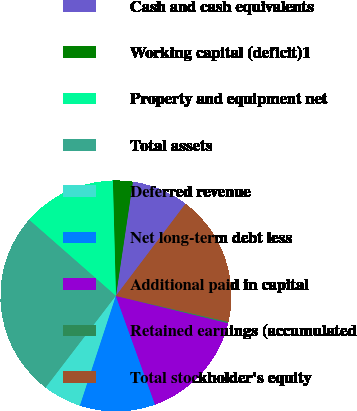Convert chart. <chart><loc_0><loc_0><loc_500><loc_500><pie_chart><fcel>Cash and cash equivalents<fcel>Working capital (deficit)1<fcel>Property and equipment net<fcel>Total assets<fcel>Deferred revenue<fcel>Net long-term debt less<fcel>Additional paid in capital<fcel>Retained earnings (accumulated<fcel>Total stockholder's equity<nl><fcel>7.95%<fcel>2.77%<fcel>13.12%<fcel>26.06%<fcel>5.36%<fcel>10.54%<fcel>15.71%<fcel>0.19%<fcel>18.3%<nl></chart> 